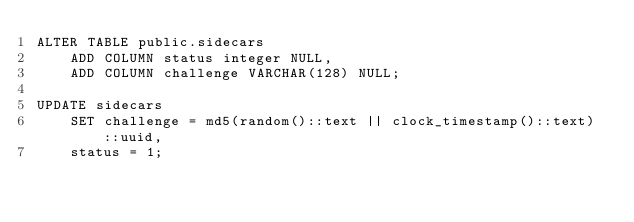Convert code to text. <code><loc_0><loc_0><loc_500><loc_500><_SQL_>ALTER TABLE public.sidecars
	ADD COLUMN status integer NULL,
	ADD COLUMN challenge VARCHAR(128) NULL;

UPDATE sidecars
	SET challenge = md5(random()::text || clock_timestamp()::text)::uuid,
	status = 1;
</code> 